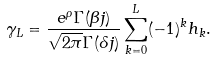Convert formula to latex. <formula><loc_0><loc_0><loc_500><loc_500>\gamma _ { L } = \frac { e ^ { \rho } \Gamma ( \beta j ) } { \sqrt { 2 \pi } \Gamma ( \delta j ) } \sum _ { k = 0 } ^ { L } ( - 1 ) ^ { k } h _ { k } .</formula> 